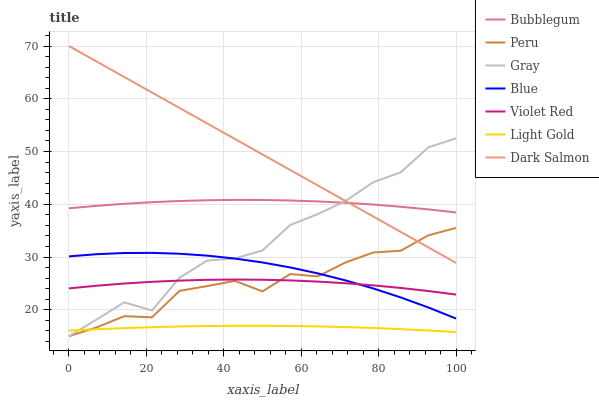Does Light Gold have the minimum area under the curve?
Answer yes or no. Yes. Does Dark Salmon have the maximum area under the curve?
Answer yes or no. Yes. Does Gray have the minimum area under the curve?
Answer yes or no. No. Does Gray have the maximum area under the curve?
Answer yes or no. No. Is Dark Salmon the smoothest?
Answer yes or no. Yes. Is Gray the roughest?
Answer yes or no. Yes. Is Violet Red the smoothest?
Answer yes or no. No. Is Violet Red the roughest?
Answer yes or no. No. Does Gray have the lowest value?
Answer yes or no. Yes. Does Violet Red have the lowest value?
Answer yes or no. No. Does Dark Salmon have the highest value?
Answer yes or no. Yes. Does Gray have the highest value?
Answer yes or no. No. Is Violet Red less than Bubblegum?
Answer yes or no. Yes. Is Dark Salmon greater than Violet Red?
Answer yes or no. Yes. Does Blue intersect Peru?
Answer yes or no. Yes. Is Blue less than Peru?
Answer yes or no. No. Is Blue greater than Peru?
Answer yes or no. No. Does Violet Red intersect Bubblegum?
Answer yes or no. No. 